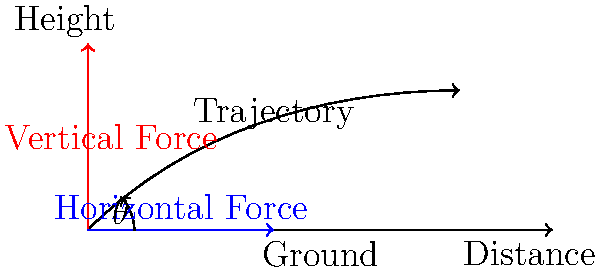As a football coach, you understand the importance of an optimal kick-off. Using the diagram provided, which shows the trajectory of a football and the force vectors acting on it, what is the optimal angle $\theta$ for maximum distance in a kick-off, assuming ideal conditions and neglecting air resistance? To determine the optimal angle for maximum distance in a kick-off, we need to consider the principles of projectile motion:

1. The motion of the football can be divided into horizontal and vertical components.

2. The horizontal component of velocity remains constant (ignoring air resistance).

3. The vertical component of velocity is affected by gravity.

4. The total time of flight depends on the initial vertical velocity.

5. The distance traveled is the product of the horizontal velocity and the time of flight.

6. The initial velocity can be broken down into horizontal and vertical components:
   - Horizontal: $v_x = v \cos\theta$
   - Vertical: $v_y = v \sin\theta$

7. The distance traveled is given by:
   $d = v_x t = (v \cos\theta) \cdot \frac{2v \sin\theta}{g}$

8. Simplifying this equation gives:
   $d = \frac{v^2}{g} \sin(2\theta)$

9. To maximize distance, we need to maximize $\sin(2\theta)$.

10. The maximum value of sine occurs at 90°.

11. Therefore, $2\theta = 90°$, or $\theta = 45°$.

This 45° angle provides the optimal balance between horizontal distance and time of flight, resulting in maximum distance for the kick-off.
Answer: 45° 